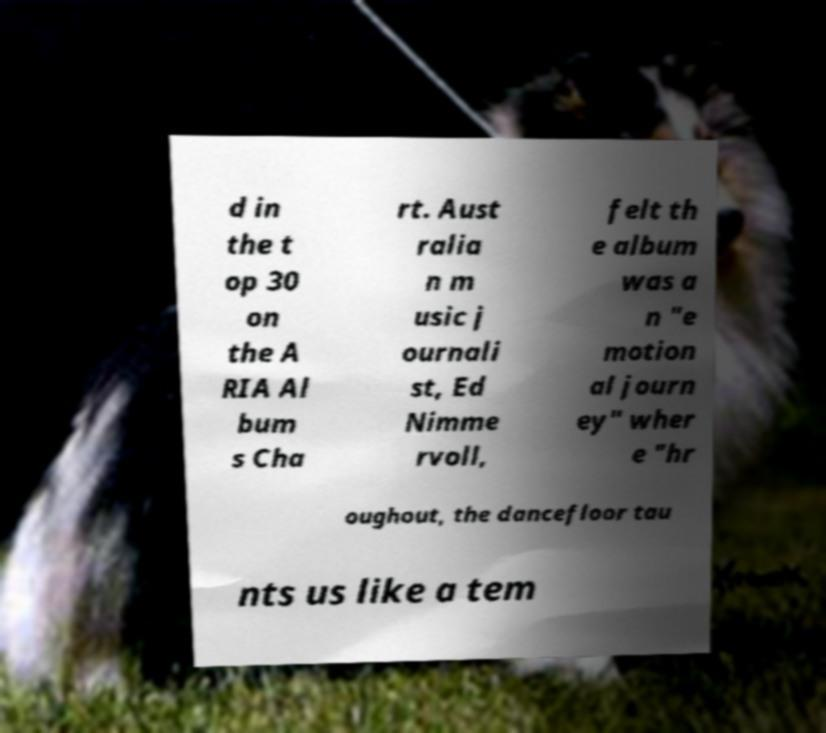There's text embedded in this image that I need extracted. Can you transcribe it verbatim? d in the t op 30 on the A RIA Al bum s Cha rt. Aust ralia n m usic j ournali st, Ed Nimme rvoll, felt th e album was a n "e motion al journ ey" wher e "hr oughout, the dancefloor tau nts us like a tem 